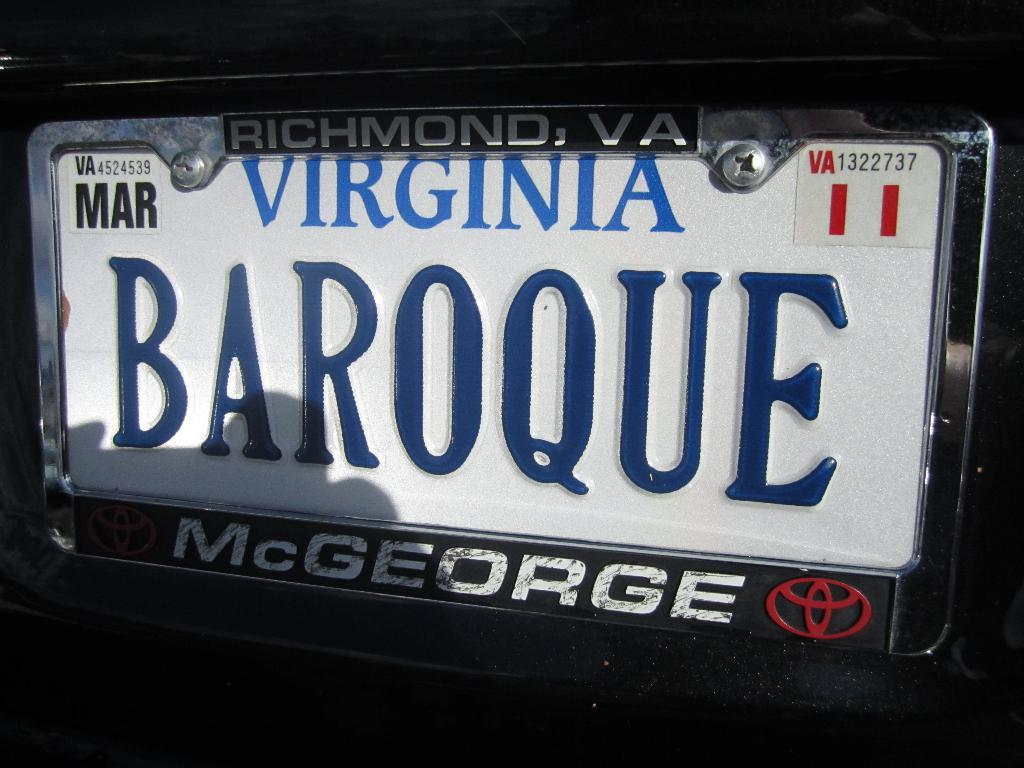Provide a one-sentence caption for the provided image. A plate from Virginia with the name McGeorge at the bottom. 